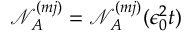Convert formula to latex. <formula><loc_0><loc_0><loc_500><loc_500>\mathcal { N } _ { A } ^ { ( m j ) } = \mathcal { N } _ { A } ^ { ( m j ) } ( \epsilon _ { 0 } ^ { 2 } t )</formula> 